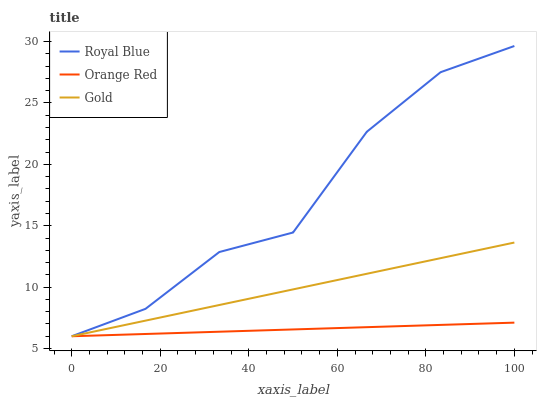Does Gold have the minimum area under the curve?
Answer yes or no. No. Does Gold have the maximum area under the curve?
Answer yes or no. No. Is Gold the smoothest?
Answer yes or no. No. Is Gold the roughest?
Answer yes or no. No. Does Gold have the highest value?
Answer yes or no. No. 